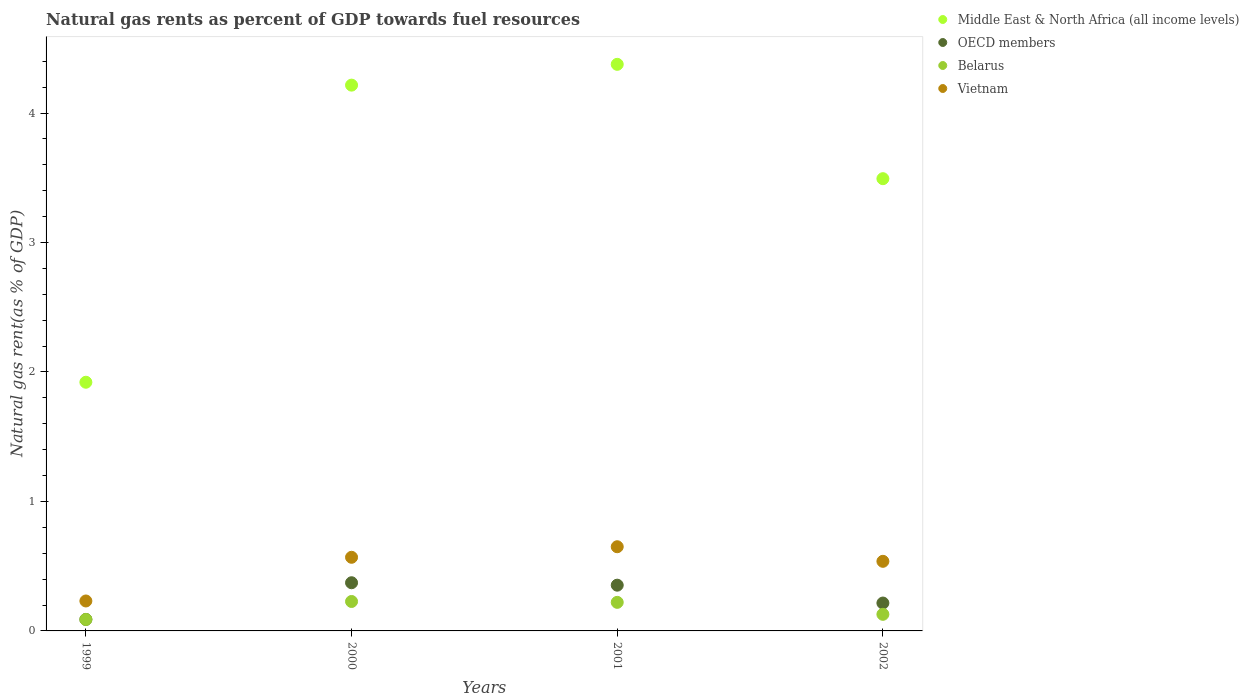Is the number of dotlines equal to the number of legend labels?
Your answer should be compact. Yes. What is the natural gas rent in Middle East & North Africa (all income levels) in 2001?
Offer a very short reply. 4.38. Across all years, what is the maximum natural gas rent in OECD members?
Offer a terse response. 0.37. Across all years, what is the minimum natural gas rent in OECD members?
Your response must be concise. 0.09. In which year was the natural gas rent in OECD members maximum?
Your answer should be very brief. 2000. In which year was the natural gas rent in Vietnam minimum?
Your answer should be very brief. 1999. What is the total natural gas rent in Belarus in the graph?
Offer a terse response. 0.66. What is the difference between the natural gas rent in Belarus in 2001 and that in 2002?
Make the answer very short. 0.09. What is the difference between the natural gas rent in Belarus in 2001 and the natural gas rent in OECD members in 2000?
Offer a terse response. -0.15. What is the average natural gas rent in Middle East & North Africa (all income levels) per year?
Your response must be concise. 3.5. In the year 2001, what is the difference between the natural gas rent in Belarus and natural gas rent in Vietnam?
Offer a very short reply. -0.43. What is the ratio of the natural gas rent in OECD members in 1999 to that in 2001?
Offer a terse response. 0.25. What is the difference between the highest and the second highest natural gas rent in Belarus?
Ensure brevity in your answer.  0.01. What is the difference between the highest and the lowest natural gas rent in Vietnam?
Ensure brevity in your answer.  0.42. How many dotlines are there?
Provide a succinct answer. 4. What is the difference between two consecutive major ticks on the Y-axis?
Provide a succinct answer. 1. Does the graph contain any zero values?
Ensure brevity in your answer.  No. Where does the legend appear in the graph?
Offer a terse response. Top right. What is the title of the graph?
Give a very brief answer. Natural gas rents as percent of GDP towards fuel resources. What is the label or title of the X-axis?
Your answer should be very brief. Years. What is the label or title of the Y-axis?
Your answer should be compact. Natural gas rent(as % of GDP). What is the Natural gas rent(as % of GDP) of Middle East & North Africa (all income levels) in 1999?
Your answer should be very brief. 1.92. What is the Natural gas rent(as % of GDP) of OECD members in 1999?
Your answer should be compact. 0.09. What is the Natural gas rent(as % of GDP) of Belarus in 1999?
Your response must be concise. 0.09. What is the Natural gas rent(as % of GDP) in Vietnam in 1999?
Give a very brief answer. 0.23. What is the Natural gas rent(as % of GDP) of Middle East & North Africa (all income levels) in 2000?
Keep it short and to the point. 4.22. What is the Natural gas rent(as % of GDP) in OECD members in 2000?
Provide a short and direct response. 0.37. What is the Natural gas rent(as % of GDP) in Belarus in 2000?
Your response must be concise. 0.23. What is the Natural gas rent(as % of GDP) in Vietnam in 2000?
Provide a short and direct response. 0.57. What is the Natural gas rent(as % of GDP) of Middle East & North Africa (all income levels) in 2001?
Your answer should be very brief. 4.38. What is the Natural gas rent(as % of GDP) of OECD members in 2001?
Ensure brevity in your answer.  0.35. What is the Natural gas rent(as % of GDP) in Belarus in 2001?
Provide a short and direct response. 0.22. What is the Natural gas rent(as % of GDP) of Vietnam in 2001?
Provide a succinct answer. 0.65. What is the Natural gas rent(as % of GDP) in Middle East & North Africa (all income levels) in 2002?
Offer a very short reply. 3.49. What is the Natural gas rent(as % of GDP) in OECD members in 2002?
Your response must be concise. 0.22. What is the Natural gas rent(as % of GDP) of Belarus in 2002?
Give a very brief answer. 0.13. What is the Natural gas rent(as % of GDP) in Vietnam in 2002?
Offer a very short reply. 0.54. Across all years, what is the maximum Natural gas rent(as % of GDP) of Middle East & North Africa (all income levels)?
Provide a succinct answer. 4.38. Across all years, what is the maximum Natural gas rent(as % of GDP) of OECD members?
Offer a terse response. 0.37. Across all years, what is the maximum Natural gas rent(as % of GDP) in Belarus?
Keep it short and to the point. 0.23. Across all years, what is the maximum Natural gas rent(as % of GDP) in Vietnam?
Your answer should be compact. 0.65. Across all years, what is the minimum Natural gas rent(as % of GDP) of Middle East & North Africa (all income levels)?
Your answer should be compact. 1.92. Across all years, what is the minimum Natural gas rent(as % of GDP) of OECD members?
Keep it short and to the point. 0.09. Across all years, what is the minimum Natural gas rent(as % of GDP) of Belarus?
Provide a succinct answer. 0.09. Across all years, what is the minimum Natural gas rent(as % of GDP) in Vietnam?
Provide a succinct answer. 0.23. What is the total Natural gas rent(as % of GDP) in Middle East & North Africa (all income levels) in the graph?
Provide a short and direct response. 14.01. What is the total Natural gas rent(as % of GDP) in OECD members in the graph?
Ensure brevity in your answer.  1.03. What is the total Natural gas rent(as % of GDP) of Belarus in the graph?
Make the answer very short. 0.66. What is the total Natural gas rent(as % of GDP) in Vietnam in the graph?
Make the answer very short. 1.99. What is the difference between the Natural gas rent(as % of GDP) of Middle East & North Africa (all income levels) in 1999 and that in 2000?
Your response must be concise. -2.29. What is the difference between the Natural gas rent(as % of GDP) in OECD members in 1999 and that in 2000?
Give a very brief answer. -0.28. What is the difference between the Natural gas rent(as % of GDP) of Belarus in 1999 and that in 2000?
Make the answer very short. -0.14. What is the difference between the Natural gas rent(as % of GDP) in Vietnam in 1999 and that in 2000?
Give a very brief answer. -0.34. What is the difference between the Natural gas rent(as % of GDP) of Middle East & North Africa (all income levels) in 1999 and that in 2001?
Ensure brevity in your answer.  -2.46. What is the difference between the Natural gas rent(as % of GDP) of OECD members in 1999 and that in 2001?
Your response must be concise. -0.26. What is the difference between the Natural gas rent(as % of GDP) of Belarus in 1999 and that in 2001?
Offer a terse response. -0.13. What is the difference between the Natural gas rent(as % of GDP) in Vietnam in 1999 and that in 2001?
Ensure brevity in your answer.  -0.42. What is the difference between the Natural gas rent(as % of GDP) of Middle East & North Africa (all income levels) in 1999 and that in 2002?
Your response must be concise. -1.57. What is the difference between the Natural gas rent(as % of GDP) of OECD members in 1999 and that in 2002?
Your response must be concise. -0.13. What is the difference between the Natural gas rent(as % of GDP) of Belarus in 1999 and that in 2002?
Ensure brevity in your answer.  -0.04. What is the difference between the Natural gas rent(as % of GDP) of Vietnam in 1999 and that in 2002?
Keep it short and to the point. -0.31. What is the difference between the Natural gas rent(as % of GDP) of Middle East & North Africa (all income levels) in 2000 and that in 2001?
Keep it short and to the point. -0.16. What is the difference between the Natural gas rent(as % of GDP) in OECD members in 2000 and that in 2001?
Provide a succinct answer. 0.02. What is the difference between the Natural gas rent(as % of GDP) in Belarus in 2000 and that in 2001?
Your response must be concise. 0.01. What is the difference between the Natural gas rent(as % of GDP) in Vietnam in 2000 and that in 2001?
Your response must be concise. -0.08. What is the difference between the Natural gas rent(as % of GDP) of Middle East & North Africa (all income levels) in 2000 and that in 2002?
Offer a terse response. 0.72. What is the difference between the Natural gas rent(as % of GDP) in OECD members in 2000 and that in 2002?
Your answer should be very brief. 0.16. What is the difference between the Natural gas rent(as % of GDP) of Belarus in 2000 and that in 2002?
Your answer should be compact. 0.1. What is the difference between the Natural gas rent(as % of GDP) in Vietnam in 2000 and that in 2002?
Provide a short and direct response. 0.03. What is the difference between the Natural gas rent(as % of GDP) of Middle East & North Africa (all income levels) in 2001 and that in 2002?
Your answer should be compact. 0.88. What is the difference between the Natural gas rent(as % of GDP) in OECD members in 2001 and that in 2002?
Ensure brevity in your answer.  0.14. What is the difference between the Natural gas rent(as % of GDP) of Belarus in 2001 and that in 2002?
Your answer should be compact. 0.09. What is the difference between the Natural gas rent(as % of GDP) of Vietnam in 2001 and that in 2002?
Ensure brevity in your answer.  0.11. What is the difference between the Natural gas rent(as % of GDP) in Middle East & North Africa (all income levels) in 1999 and the Natural gas rent(as % of GDP) in OECD members in 2000?
Give a very brief answer. 1.55. What is the difference between the Natural gas rent(as % of GDP) of Middle East & North Africa (all income levels) in 1999 and the Natural gas rent(as % of GDP) of Belarus in 2000?
Offer a very short reply. 1.69. What is the difference between the Natural gas rent(as % of GDP) in Middle East & North Africa (all income levels) in 1999 and the Natural gas rent(as % of GDP) in Vietnam in 2000?
Give a very brief answer. 1.35. What is the difference between the Natural gas rent(as % of GDP) of OECD members in 1999 and the Natural gas rent(as % of GDP) of Belarus in 2000?
Offer a terse response. -0.14. What is the difference between the Natural gas rent(as % of GDP) in OECD members in 1999 and the Natural gas rent(as % of GDP) in Vietnam in 2000?
Make the answer very short. -0.48. What is the difference between the Natural gas rent(as % of GDP) in Belarus in 1999 and the Natural gas rent(as % of GDP) in Vietnam in 2000?
Your answer should be compact. -0.48. What is the difference between the Natural gas rent(as % of GDP) of Middle East & North Africa (all income levels) in 1999 and the Natural gas rent(as % of GDP) of OECD members in 2001?
Make the answer very short. 1.57. What is the difference between the Natural gas rent(as % of GDP) in Middle East & North Africa (all income levels) in 1999 and the Natural gas rent(as % of GDP) in Vietnam in 2001?
Offer a terse response. 1.27. What is the difference between the Natural gas rent(as % of GDP) of OECD members in 1999 and the Natural gas rent(as % of GDP) of Belarus in 2001?
Your answer should be compact. -0.13. What is the difference between the Natural gas rent(as % of GDP) in OECD members in 1999 and the Natural gas rent(as % of GDP) in Vietnam in 2001?
Your response must be concise. -0.56. What is the difference between the Natural gas rent(as % of GDP) of Belarus in 1999 and the Natural gas rent(as % of GDP) of Vietnam in 2001?
Give a very brief answer. -0.56. What is the difference between the Natural gas rent(as % of GDP) in Middle East & North Africa (all income levels) in 1999 and the Natural gas rent(as % of GDP) in OECD members in 2002?
Your answer should be compact. 1.71. What is the difference between the Natural gas rent(as % of GDP) of Middle East & North Africa (all income levels) in 1999 and the Natural gas rent(as % of GDP) of Belarus in 2002?
Offer a terse response. 1.79. What is the difference between the Natural gas rent(as % of GDP) in Middle East & North Africa (all income levels) in 1999 and the Natural gas rent(as % of GDP) in Vietnam in 2002?
Your answer should be compact. 1.38. What is the difference between the Natural gas rent(as % of GDP) in OECD members in 1999 and the Natural gas rent(as % of GDP) in Belarus in 2002?
Your answer should be compact. -0.04. What is the difference between the Natural gas rent(as % of GDP) in OECD members in 1999 and the Natural gas rent(as % of GDP) in Vietnam in 2002?
Offer a very short reply. -0.45. What is the difference between the Natural gas rent(as % of GDP) of Belarus in 1999 and the Natural gas rent(as % of GDP) of Vietnam in 2002?
Give a very brief answer. -0.45. What is the difference between the Natural gas rent(as % of GDP) of Middle East & North Africa (all income levels) in 2000 and the Natural gas rent(as % of GDP) of OECD members in 2001?
Your answer should be very brief. 3.86. What is the difference between the Natural gas rent(as % of GDP) of Middle East & North Africa (all income levels) in 2000 and the Natural gas rent(as % of GDP) of Belarus in 2001?
Make the answer very short. 3.99. What is the difference between the Natural gas rent(as % of GDP) of Middle East & North Africa (all income levels) in 2000 and the Natural gas rent(as % of GDP) of Vietnam in 2001?
Keep it short and to the point. 3.57. What is the difference between the Natural gas rent(as % of GDP) in OECD members in 2000 and the Natural gas rent(as % of GDP) in Belarus in 2001?
Ensure brevity in your answer.  0.15. What is the difference between the Natural gas rent(as % of GDP) of OECD members in 2000 and the Natural gas rent(as % of GDP) of Vietnam in 2001?
Offer a terse response. -0.28. What is the difference between the Natural gas rent(as % of GDP) of Belarus in 2000 and the Natural gas rent(as % of GDP) of Vietnam in 2001?
Your answer should be compact. -0.42. What is the difference between the Natural gas rent(as % of GDP) in Middle East & North Africa (all income levels) in 2000 and the Natural gas rent(as % of GDP) in OECD members in 2002?
Offer a terse response. 4. What is the difference between the Natural gas rent(as % of GDP) in Middle East & North Africa (all income levels) in 2000 and the Natural gas rent(as % of GDP) in Belarus in 2002?
Ensure brevity in your answer.  4.09. What is the difference between the Natural gas rent(as % of GDP) in Middle East & North Africa (all income levels) in 2000 and the Natural gas rent(as % of GDP) in Vietnam in 2002?
Ensure brevity in your answer.  3.68. What is the difference between the Natural gas rent(as % of GDP) in OECD members in 2000 and the Natural gas rent(as % of GDP) in Belarus in 2002?
Your answer should be compact. 0.24. What is the difference between the Natural gas rent(as % of GDP) in OECD members in 2000 and the Natural gas rent(as % of GDP) in Vietnam in 2002?
Offer a terse response. -0.17. What is the difference between the Natural gas rent(as % of GDP) of Belarus in 2000 and the Natural gas rent(as % of GDP) of Vietnam in 2002?
Provide a succinct answer. -0.31. What is the difference between the Natural gas rent(as % of GDP) in Middle East & North Africa (all income levels) in 2001 and the Natural gas rent(as % of GDP) in OECD members in 2002?
Ensure brevity in your answer.  4.16. What is the difference between the Natural gas rent(as % of GDP) in Middle East & North Africa (all income levels) in 2001 and the Natural gas rent(as % of GDP) in Belarus in 2002?
Give a very brief answer. 4.25. What is the difference between the Natural gas rent(as % of GDP) of Middle East & North Africa (all income levels) in 2001 and the Natural gas rent(as % of GDP) of Vietnam in 2002?
Your answer should be very brief. 3.84. What is the difference between the Natural gas rent(as % of GDP) in OECD members in 2001 and the Natural gas rent(as % of GDP) in Belarus in 2002?
Give a very brief answer. 0.23. What is the difference between the Natural gas rent(as % of GDP) of OECD members in 2001 and the Natural gas rent(as % of GDP) of Vietnam in 2002?
Offer a terse response. -0.18. What is the difference between the Natural gas rent(as % of GDP) of Belarus in 2001 and the Natural gas rent(as % of GDP) of Vietnam in 2002?
Provide a succinct answer. -0.32. What is the average Natural gas rent(as % of GDP) of Middle East & North Africa (all income levels) per year?
Your answer should be very brief. 3.5. What is the average Natural gas rent(as % of GDP) of OECD members per year?
Give a very brief answer. 0.26. What is the average Natural gas rent(as % of GDP) of Belarus per year?
Your response must be concise. 0.17. What is the average Natural gas rent(as % of GDP) of Vietnam per year?
Give a very brief answer. 0.5. In the year 1999, what is the difference between the Natural gas rent(as % of GDP) of Middle East & North Africa (all income levels) and Natural gas rent(as % of GDP) of OECD members?
Your answer should be very brief. 1.83. In the year 1999, what is the difference between the Natural gas rent(as % of GDP) in Middle East & North Africa (all income levels) and Natural gas rent(as % of GDP) in Belarus?
Ensure brevity in your answer.  1.83. In the year 1999, what is the difference between the Natural gas rent(as % of GDP) of Middle East & North Africa (all income levels) and Natural gas rent(as % of GDP) of Vietnam?
Your answer should be compact. 1.69. In the year 1999, what is the difference between the Natural gas rent(as % of GDP) of OECD members and Natural gas rent(as % of GDP) of Belarus?
Your response must be concise. 0. In the year 1999, what is the difference between the Natural gas rent(as % of GDP) in OECD members and Natural gas rent(as % of GDP) in Vietnam?
Ensure brevity in your answer.  -0.14. In the year 1999, what is the difference between the Natural gas rent(as % of GDP) of Belarus and Natural gas rent(as % of GDP) of Vietnam?
Offer a very short reply. -0.14. In the year 2000, what is the difference between the Natural gas rent(as % of GDP) of Middle East & North Africa (all income levels) and Natural gas rent(as % of GDP) of OECD members?
Your answer should be very brief. 3.84. In the year 2000, what is the difference between the Natural gas rent(as % of GDP) in Middle East & North Africa (all income levels) and Natural gas rent(as % of GDP) in Belarus?
Your answer should be very brief. 3.99. In the year 2000, what is the difference between the Natural gas rent(as % of GDP) of Middle East & North Africa (all income levels) and Natural gas rent(as % of GDP) of Vietnam?
Offer a terse response. 3.65. In the year 2000, what is the difference between the Natural gas rent(as % of GDP) in OECD members and Natural gas rent(as % of GDP) in Belarus?
Your answer should be compact. 0.14. In the year 2000, what is the difference between the Natural gas rent(as % of GDP) of OECD members and Natural gas rent(as % of GDP) of Vietnam?
Your response must be concise. -0.2. In the year 2000, what is the difference between the Natural gas rent(as % of GDP) in Belarus and Natural gas rent(as % of GDP) in Vietnam?
Ensure brevity in your answer.  -0.34. In the year 2001, what is the difference between the Natural gas rent(as % of GDP) of Middle East & North Africa (all income levels) and Natural gas rent(as % of GDP) of OECD members?
Your answer should be compact. 4.02. In the year 2001, what is the difference between the Natural gas rent(as % of GDP) of Middle East & North Africa (all income levels) and Natural gas rent(as % of GDP) of Belarus?
Your answer should be compact. 4.16. In the year 2001, what is the difference between the Natural gas rent(as % of GDP) of Middle East & North Africa (all income levels) and Natural gas rent(as % of GDP) of Vietnam?
Provide a short and direct response. 3.73. In the year 2001, what is the difference between the Natural gas rent(as % of GDP) of OECD members and Natural gas rent(as % of GDP) of Belarus?
Provide a short and direct response. 0.13. In the year 2001, what is the difference between the Natural gas rent(as % of GDP) of OECD members and Natural gas rent(as % of GDP) of Vietnam?
Your answer should be very brief. -0.3. In the year 2001, what is the difference between the Natural gas rent(as % of GDP) of Belarus and Natural gas rent(as % of GDP) of Vietnam?
Provide a short and direct response. -0.43. In the year 2002, what is the difference between the Natural gas rent(as % of GDP) in Middle East & North Africa (all income levels) and Natural gas rent(as % of GDP) in OECD members?
Ensure brevity in your answer.  3.28. In the year 2002, what is the difference between the Natural gas rent(as % of GDP) of Middle East & North Africa (all income levels) and Natural gas rent(as % of GDP) of Belarus?
Make the answer very short. 3.36. In the year 2002, what is the difference between the Natural gas rent(as % of GDP) in Middle East & North Africa (all income levels) and Natural gas rent(as % of GDP) in Vietnam?
Offer a very short reply. 2.96. In the year 2002, what is the difference between the Natural gas rent(as % of GDP) in OECD members and Natural gas rent(as % of GDP) in Belarus?
Keep it short and to the point. 0.09. In the year 2002, what is the difference between the Natural gas rent(as % of GDP) in OECD members and Natural gas rent(as % of GDP) in Vietnam?
Offer a terse response. -0.32. In the year 2002, what is the difference between the Natural gas rent(as % of GDP) in Belarus and Natural gas rent(as % of GDP) in Vietnam?
Give a very brief answer. -0.41. What is the ratio of the Natural gas rent(as % of GDP) of Middle East & North Africa (all income levels) in 1999 to that in 2000?
Keep it short and to the point. 0.46. What is the ratio of the Natural gas rent(as % of GDP) in OECD members in 1999 to that in 2000?
Keep it short and to the point. 0.24. What is the ratio of the Natural gas rent(as % of GDP) in Belarus in 1999 to that in 2000?
Provide a succinct answer. 0.39. What is the ratio of the Natural gas rent(as % of GDP) in Vietnam in 1999 to that in 2000?
Your answer should be compact. 0.41. What is the ratio of the Natural gas rent(as % of GDP) of Middle East & North Africa (all income levels) in 1999 to that in 2001?
Ensure brevity in your answer.  0.44. What is the ratio of the Natural gas rent(as % of GDP) in OECD members in 1999 to that in 2001?
Provide a short and direct response. 0.25. What is the ratio of the Natural gas rent(as % of GDP) in Belarus in 1999 to that in 2001?
Give a very brief answer. 0.4. What is the ratio of the Natural gas rent(as % of GDP) in Vietnam in 1999 to that in 2001?
Give a very brief answer. 0.36. What is the ratio of the Natural gas rent(as % of GDP) of Middle East & North Africa (all income levels) in 1999 to that in 2002?
Offer a terse response. 0.55. What is the ratio of the Natural gas rent(as % of GDP) of OECD members in 1999 to that in 2002?
Ensure brevity in your answer.  0.41. What is the ratio of the Natural gas rent(as % of GDP) in Belarus in 1999 to that in 2002?
Your answer should be compact. 0.69. What is the ratio of the Natural gas rent(as % of GDP) of Vietnam in 1999 to that in 2002?
Provide a short and direct response. 0.43. What is the ratio of the Natural gas rent(as % of GDP) of Middle East & North Africa (all income levels) in 2000 to that in 2001?
Give a very brief answer. 0.96. What is the ratio of the Natural gas rent(as % of GDP) of OECD members in 2000 to that in 2001?
Provide a succinct answer. 1.05. What is the ratio of the Natural gas rent(as % of GDP) of Belarus in 2000 to that in 2001?
Provide a succinct answer. 1.03. What is the ratio of the Natural gas rent(as % of GDP) in Vietnam in 2000 to that in 2001?
Offer a very short reply. 0.87. What is the ratio of the Natural gas rent(as % of GDP) in Middle East & North Africa (all income levels) in 2000 to that in 2002?
Your answer should be compact. 1.21. What is the ratio of the Natural gas rent(as % of GDP) in OECD members in 2000 to that in 2002?
Your response must be concise. 1.73. What is the ratio of the Natural gas rent(as % of GDP) in Belarus in 2000 to that in 2002?
Make the answer very short. 1.77. What is the ratio of the Natural gas rent(as % of GDP) of Vietnam in 2000 to that in 2002?
Your answer should be very brief. 1.06. What is the ratio of the Natural gas rent(as % of GDP) in Middle East & North Africa (all income levels) in 2001 to that in 2002?
Offer a very short reply. 1.25. What is the ratio of the Natural gas rent(as % of GDP) in OECD members in 2001 to that in 2002?
Keep it short and to the point. 1.64. What is the ratio of the Natural gas rent(as % of GDP) in Belarus in 2001 to that in 2002?
Your answer should be compact. 1.72. What is the ratio of the Natural gas rent(as % of GDP) in Vietnam in 2001 to that in 2002?
Offer a very short reply. 1.21. What is the difference between the highest and the second highest Natural gas rent(as % of GDP) in Middle East & North Africa (all income levels)?
Offer a terse response. 0.16. What is the difference between the highest and the second highest Natural gas rent(as % of GDP) of OECD members?
Your response must be concise. 0.02. What is the difference between the highest and the second highest Natural gas rent(as % of GDP) of Belarus?
Your answer should be very brief. 0.01. What is the difference between the highest and the second highest Natural gas rent(as % of GDP) of Vietnam?
Keep it short and to the point. 0.08. What is the difference between the highest and the lowest Natural gas rent(as % of GDP) of Middle East & North Africa (all income levels)?
Keep it short and to the point. 2.46. What is the difference between the highest and the lowest Natural gas rent(as % of GDP) of OECD members?
Provide a short and direct response. 0.28. What is the difference between the highest and the lowest Natural gas rent(as % of GDP) in Belarus?
Provide a succinct answer. 0.14. What is the difference between the highest and the lowest Natural gas rent(as % of GDP) in Vietnam?
Offer a terse response. 0.42. 